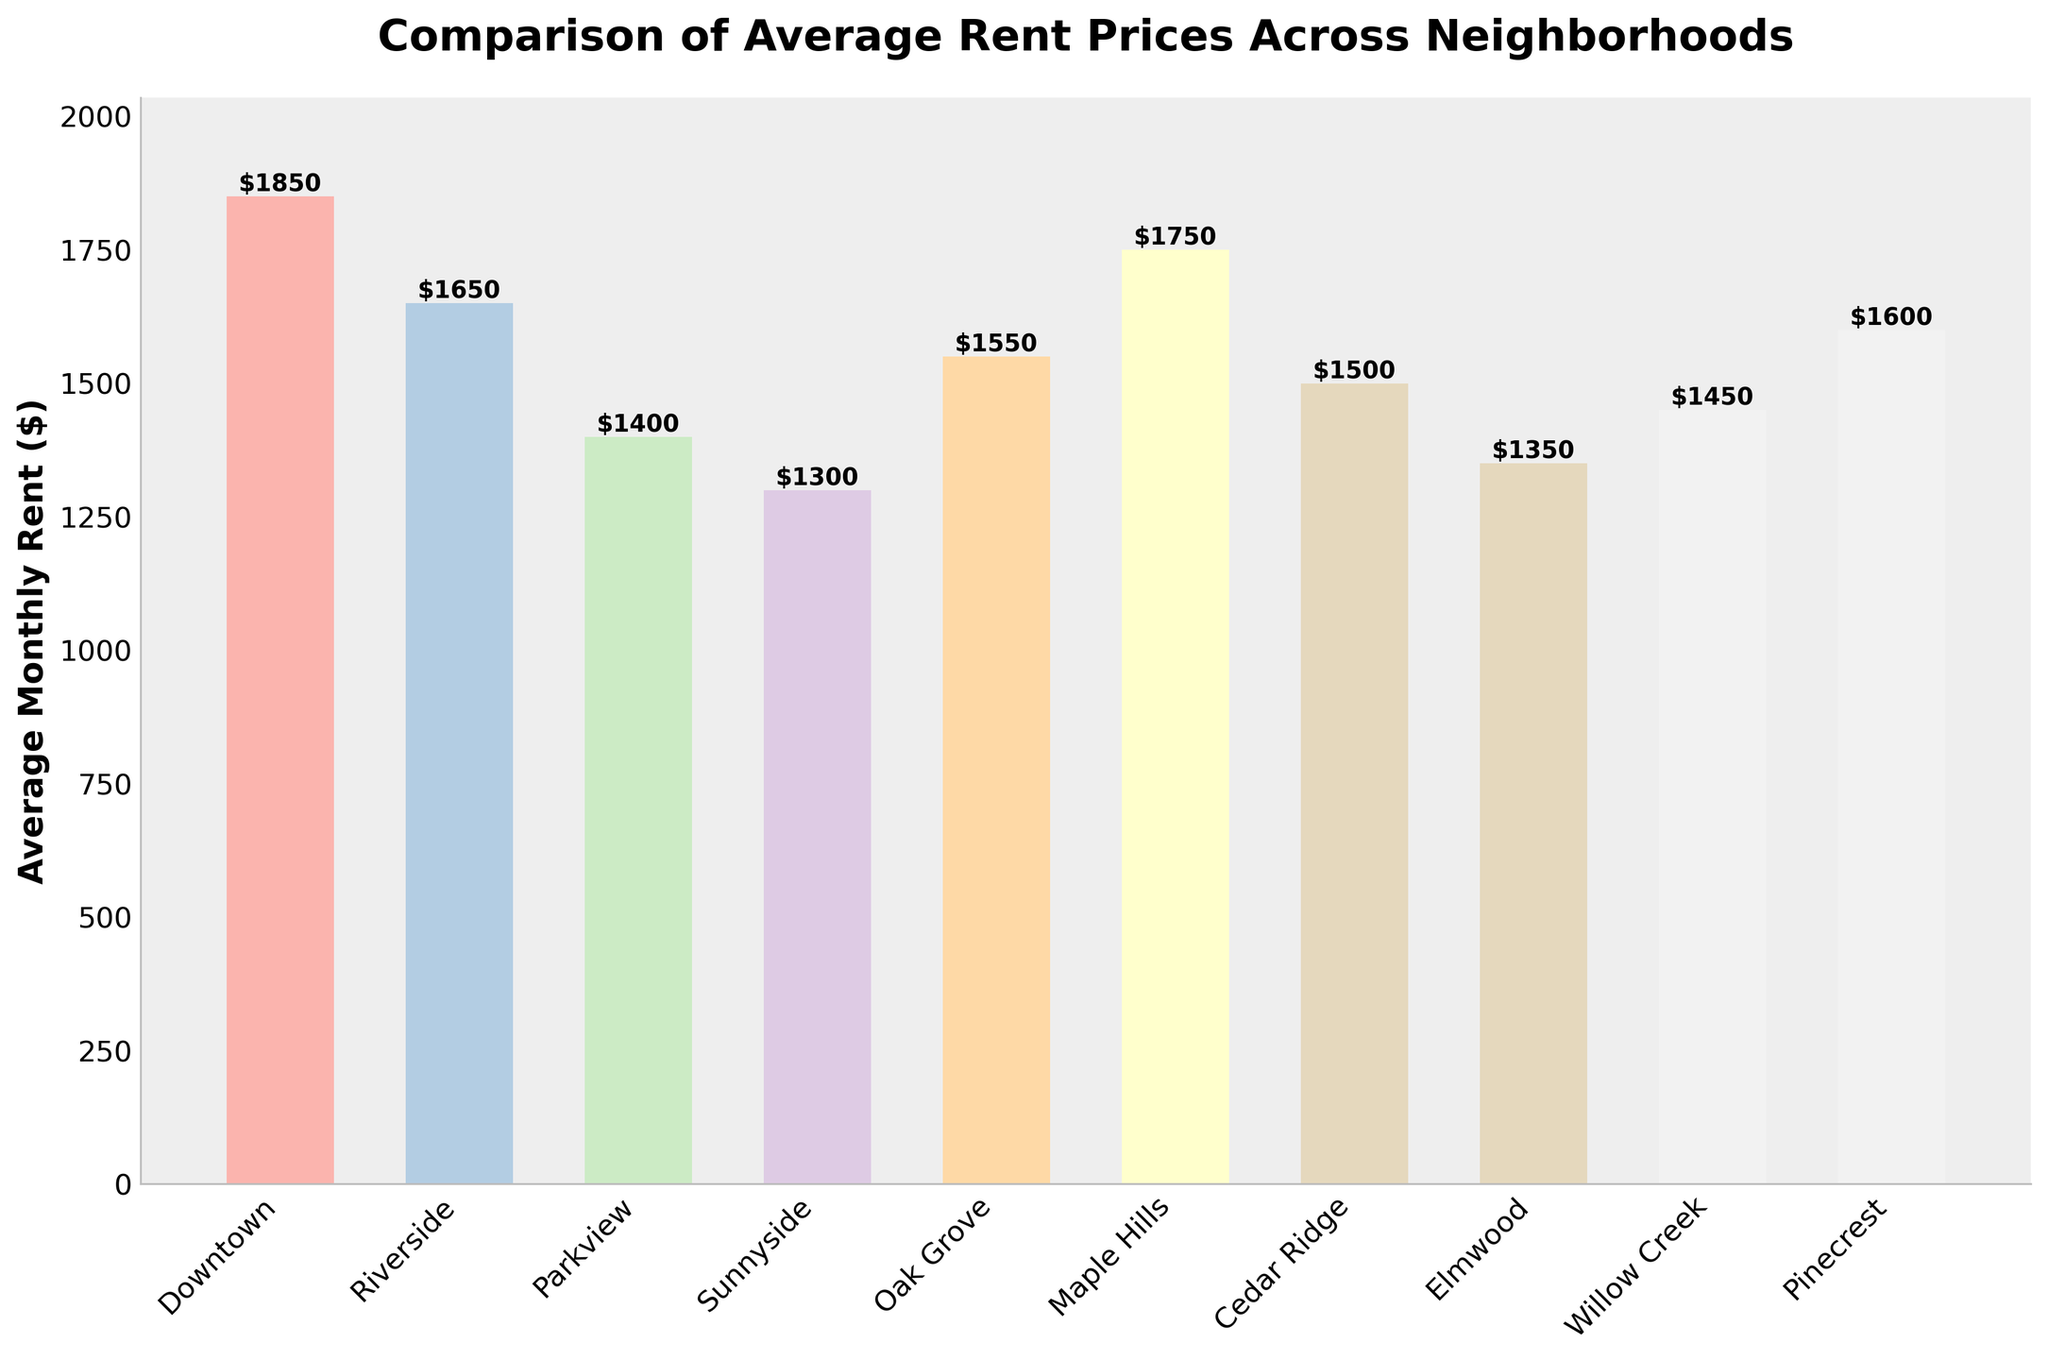What neighborhood has the highest average monthly rent? By examining the heights of the bars, the highest bar corresponds to the neighborhood which has the highest average monthly rent. Downtown has the highest bar with a rent of $1850.
Answer: Downtown What is the difference in average monthly rent between Willow Creek and Cedar Ridge? Subtract the average monthly rent of Cedar Ridge from that of Willow Creek to find the difference. Willow Creek is $1450 and Cedar Ridge is $1500, so $1500 - $1450 = $50.
Answer: $50 Which neighborhood has a lower average monthly rent, Oak Grove or Maple Hills? Compare the heights of the bars for Oak Grove and Maple Hills. Oak Grove has an average rent of $1550 and Maple Hills has $1750. Therefore, Oak Grove has a lower rent.
Answer: Oak Grove What is the average monthly rent for the least expensive neighborhood, and which neighborhood is it? Identify the bar with the shortest height which represents the least expensive neighborhood. Sunnyside has the shortest bar with an average rent of $1300.
Answer: Sunnyside, $1300 How much higher is the average rent in Downtown compared to the median rent across all neighborhoods? First, calculate the median rent by ordering the rents and finding the middle value. Sorted: $1300, $1350, $1400, $1450, $1500, $1550, $1600, $1650, $1750, $1850. The median is ($1500 + $1550)/2 = $1525. Then, subtract the median from Downtown's rent: $1850 - $1525 = $325.
Answer: $325 What is the range of average monthly rent prices across all neighborhoods? The range is found by subtracting the lowest average rent from the highest average rent. The highest is Downtown at $1850, and the lowest is Sunnyside at $1300. Therefore, $1850 - $1300 = $550.
Answer: $550 Which neighborhoods have an average rent very close to $1500? Look for bars corresponding to neighborhoods with average rents near $1500. Cedar Ridge ($1500) and Willow Creek ($1450) are very close to $1500.
Answer: Cedar Ridge, Willow Creek How many neighborhoods have a higher average monthly rent than Parkview? Identify the rent for Parkview ($1400) and count the number of neighborhoods with higher rents. The neighborhoods are Downtown, Riverside, Oak Grove, Maple Hills, Cedar Ridge, Willow Creek, and Pinecrest, totaling 7 neighborhoods.
Answer: 7 Which neighborhood has a rent closest to the average rent of all neighborhoods? First, calculate the average rent: (1850 + 1650 + 1400 + 1300 + 1550 + 1750 + 1500 + 1350 + 1450 + 1600)/10 = $1540. Then, identify the neighborhood with the rent closest to $1540. Oak Grove has a rent of $1550, which is closest.
Answer: Oak Grove 